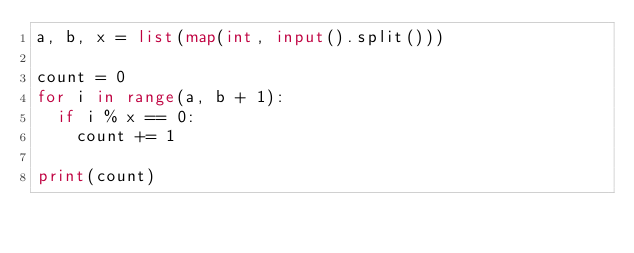<code> <loc_0><loc_0><loc_500><loc_500><_Python_>a, b, x = list(map(int, input().split()))

count = 0
for i in range(a, b + 1):
  if i % x == 0:
    count += 1

print(count)
</code> 